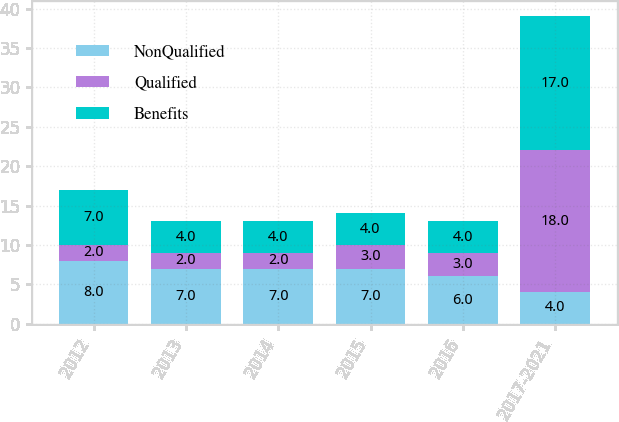Convert chart. <chart><loc_0><loc_0><loc_500><loc_500><stacked_bar_chart><ecel><fcel>2012<fcel>2013<fcel>2014<fcel>2015<fcel>2016<fcel>2017-2021<nl><fcel>NonQualified<fcel>8<fcel>7<fcel>7<fcel>7<fcel>6<fcel>4<nl><fcel>Qualified<fcel>2<fcel>2<fcel>2<fcel>3<fcel>3<fcel>18<nl><fcel>Benefits<fcel>7<fcel>4<fcel>4<fcel>4<fcel>4<fcel>17<nl></chart> 